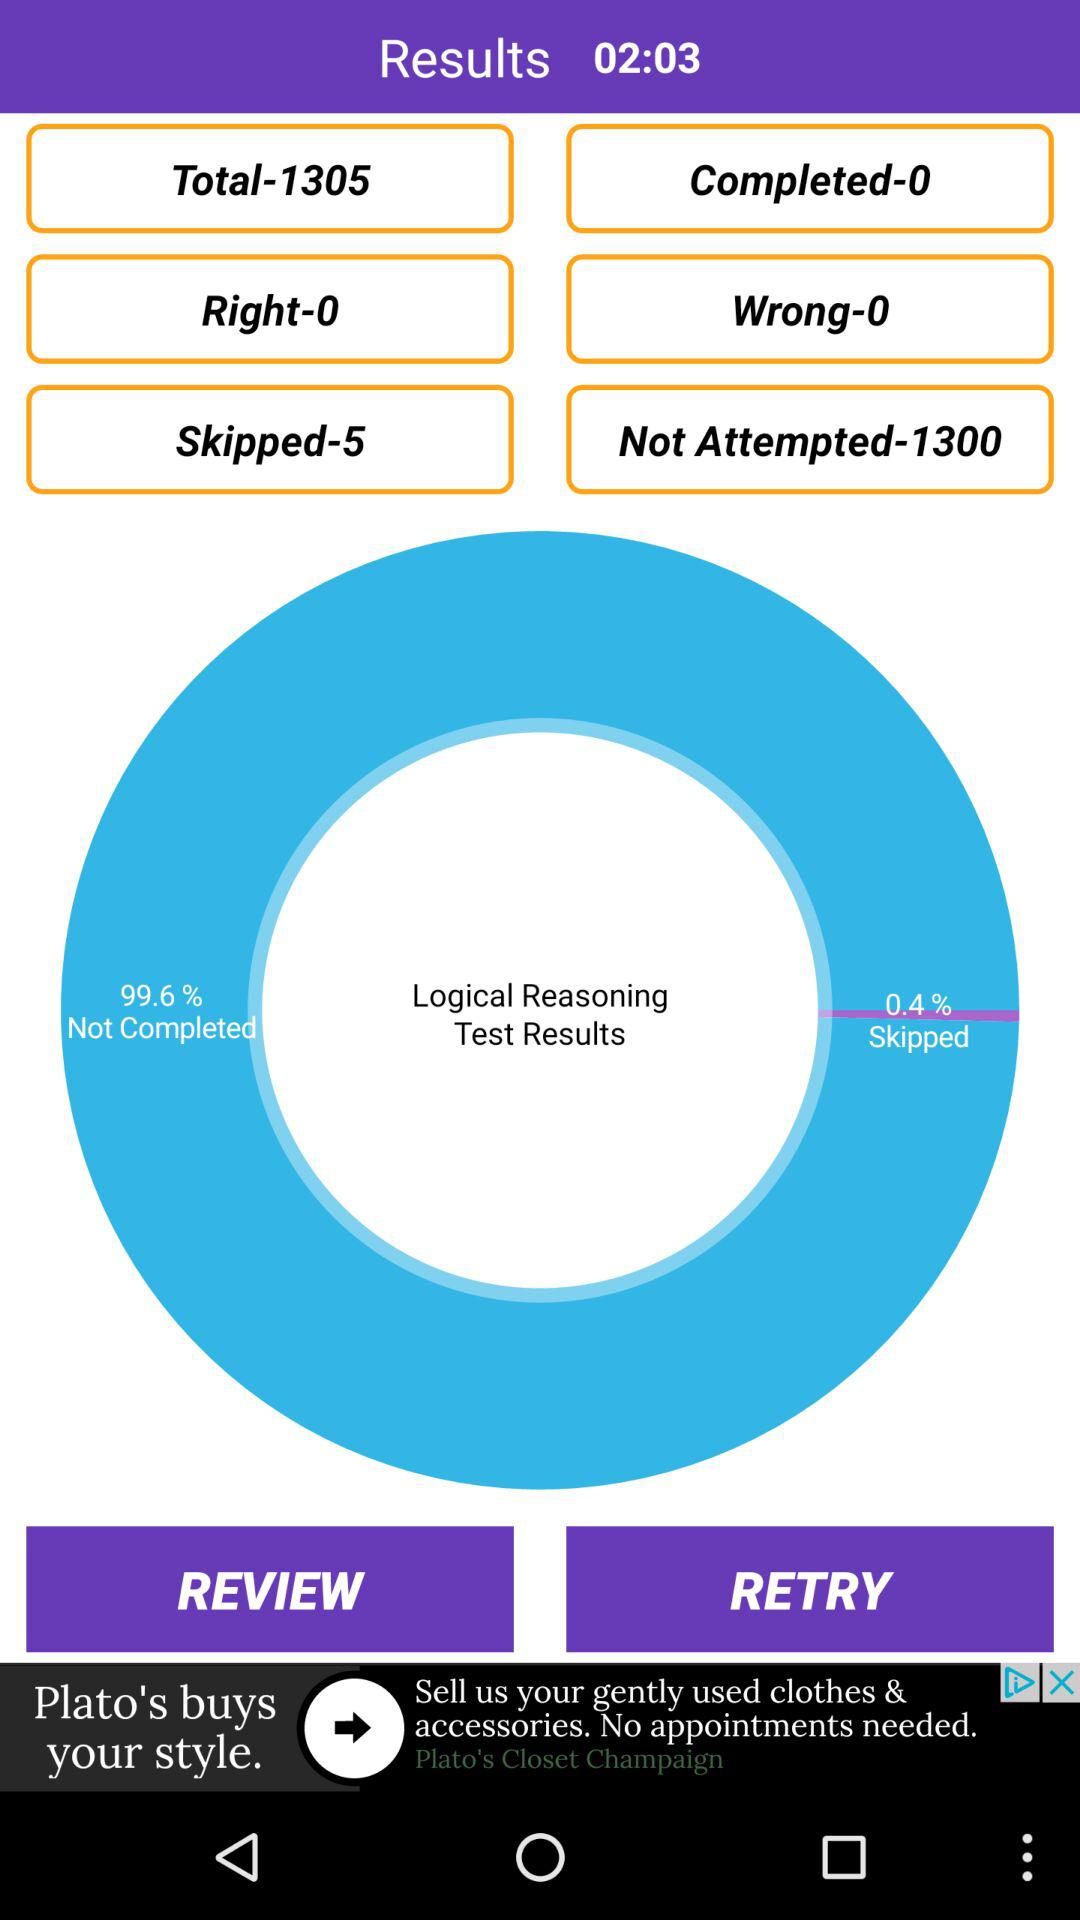How much of that percentage is for "Skipped Logical Reasoning Test Results"? The percentage is 0.4 %. 